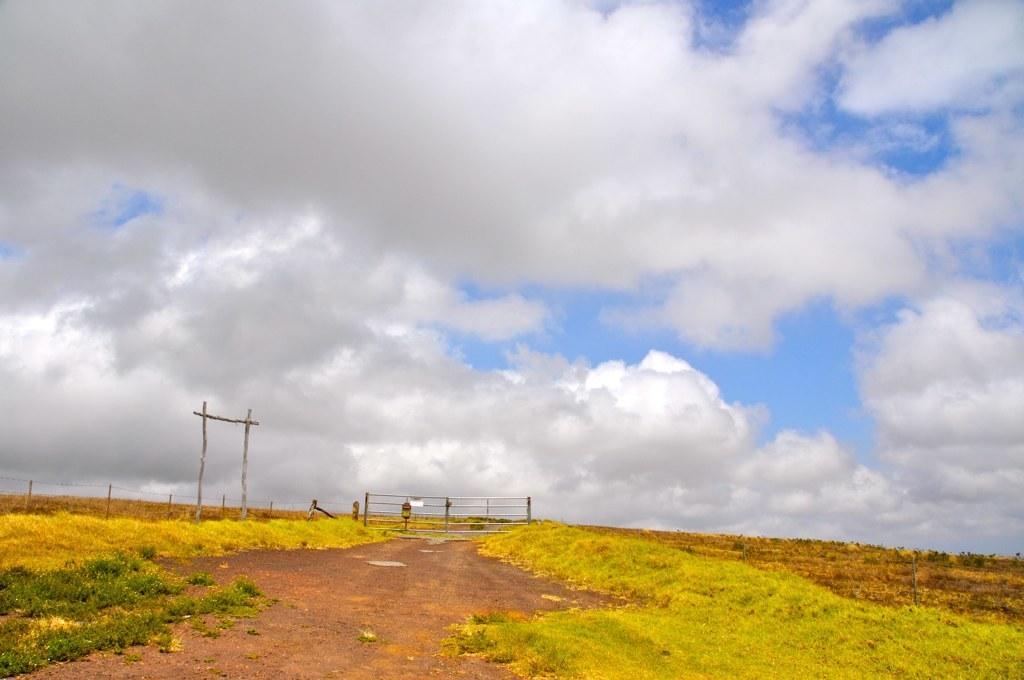In one or two sentences, can you explain what this image depicts? In this image there is the sky, there are clouds in the sky, there is fencing, there is board, there is grass, there is grass truncated towards the bottom of the image, there is grass truncated towards the left of the image. 